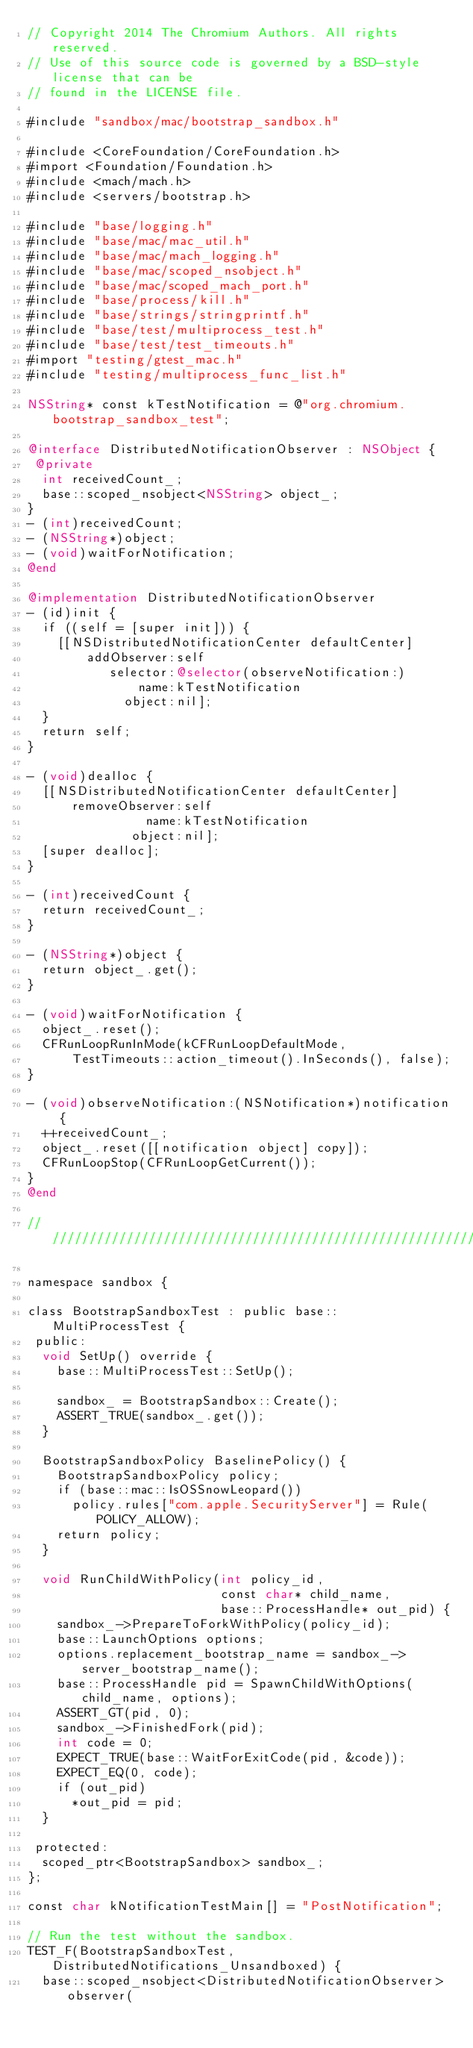<code> <loc_0><loc_0><loc_500><loc_500><_ObjectiveC_>// Copyright 2014 The Chromium Authors. All rights reserved.
// Use of this source code is governed by a BSD-style license that can be
// found in the LICENSE file.

#include "sandbox/mac/bootstrap_sandbox.h"

#include <CoreFoundation/CoreFoundation.h>
#import <Foundation/Foundation.h>
#include <mach/mach.h>
#include <servers/bootstrap.h>

#include "base/logging.h"
#include "base/mac/mac_util.h"
#include "base/mac/mach_logging.h"
#include "base/mac/scoped_nsobject.h"
#include "base/mac/scoped_mach_port.h"
#include "base/process/kill.h"
#include "base/strings/stringprintf.h"
#include "base/test/multiprocess_test.h"
#include "base/test/test_timeouts.h"
#import "testing/gtest_mac.h"
#include "testing/multiprocess_func_list.h"

NSString* const kTestNotification = @"org.chromium.bootstrap_sandbox_test";

@interface DistributedNotificationObserver : NSObject {
 @private
  int receivedCount_;
  base::scoped_nsobject<NSString> object_;
}
- (int)receivedCount;
- (NSString*)object;
- (void)waitForNotification;
@end

@implementation DistributedNotificationObserver
- (id)init {
  if ((self = [super init])) {
    [[NSDistributedNotificationCenter defaultCenter]
        addObserver:self
           selector:@selector(observeNotification:)
               name:kTestNotification
             object:nil];
  }
  return self;
}

- (void)dealloc {
  [[NSDistributedNotificationCenter defaultCenter]
      removeObserver:self
                name:kTestNotification
              object:nil];
  [super dealloc];
}

- (int)receivedCount {
  return receivedCount_;
}

- (NSString*)object {
  return object_.get();
}

- (void)waitForNotification {
  object_.reset();
  CFRunLoopRunInMode(kCFRunLoopDefaultMode,
      TestTimeouts::action_timeout().InSeconds(), false);
}

- (void)observeNotification:(NSNotification*)notification {
  ++receivedCount_;
  object_.reset([[notification object] copy]);
  CFRunLoopStop(CFRunLoopGetCurrent());
}
@end

////////////////////////////////////////////////////////////////////////////////

namespace sandbox {

class BootstrapSandboxTest : public base::MultiProcessTest {
 public:
  void SetUp() override {
    base::MultiProcessTest::SetUp();

    sandbox_ = BootstrapSandbox::Create();
    ASSERT_TRUE(sandbox_.get());
  }

  BootstrapSandboxPolicy BaselinePolicy() {
    BootstrapSandboxPolicy policy;
    if (base::mac::IsOSSnowLeopard())
      policy.rules["com.apple.SecurityServer"] = Rule(POLICY_ALLOW);
    return policy;
  }

  void RunChildWithPolicy(int policy_id,
                          const char* child_name,
                          base::ProcessHandle* out_pid) {
    sandbox_->PrepareToForkWithPolicy(policy_id);
    base::LaunchOptions options;
    options.replacement_bootstrap_name = sandbox_->server_bootstrap_name();
    base::ProcessHandle pid = SpawnChildWithOptions(child_name, options);
    ASSERT_GT(pid, 0);
    sandbox_->FinishedFork(pid);
    int code = 0;
    EXPECT_TRUE(base::WaitForExitCode(pid, &code));
    EXPECT_EQ(0, code);
    if (out_pid)
      *out_pid = pid;
  }

 protected:
  scoped_ptr<BootstrapSandbox> sandbox_;
};

const char kNotificationTestMain[] = "PostNotification";

// Run the test without the sandbox.
TEST_F(BootstrapSandboxTest, DistributedNotifications_Unsandboxed) {
  base::scoped_nsobject<DistributedNotificationObserver> observer(</code> 